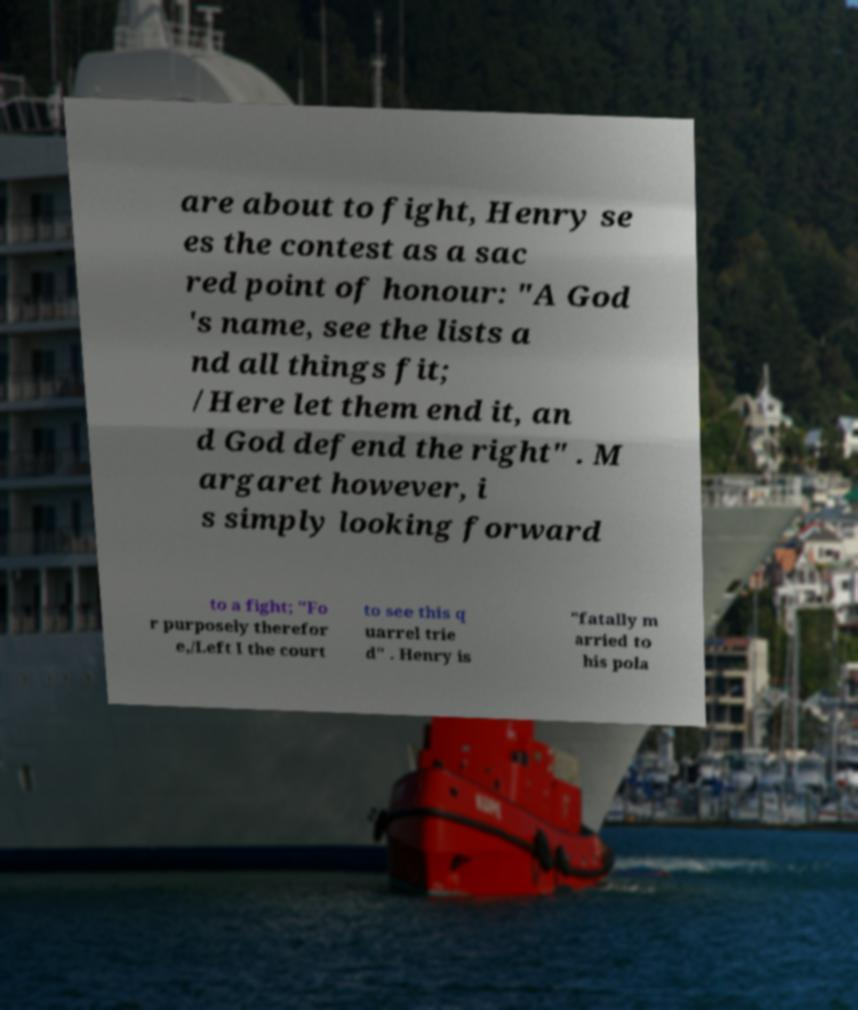I need the written content from this picture converted into text. Can you do that? are about to fight, Henry se es the contest as a sac red point of honour: "A God 's name, see the lists a nd all things fit; /Here let them end it, an d God defend the right" . M argaret however, i s simply looking forward to a fight; "Fo r purposely therefor e,/Left I the court to see this q uarrel trie d" . Henry is "fatally m arried to his pola 